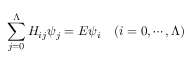<formula> <loc_0><loc_0><loc_500><loc_500>\sum _ { j = 0 } ^ { \Lambda } H _ { i j } \psi _ { j } = E \psi _ { i } \quad ( i = 0 , \cdots , \Lambda )</formula> 